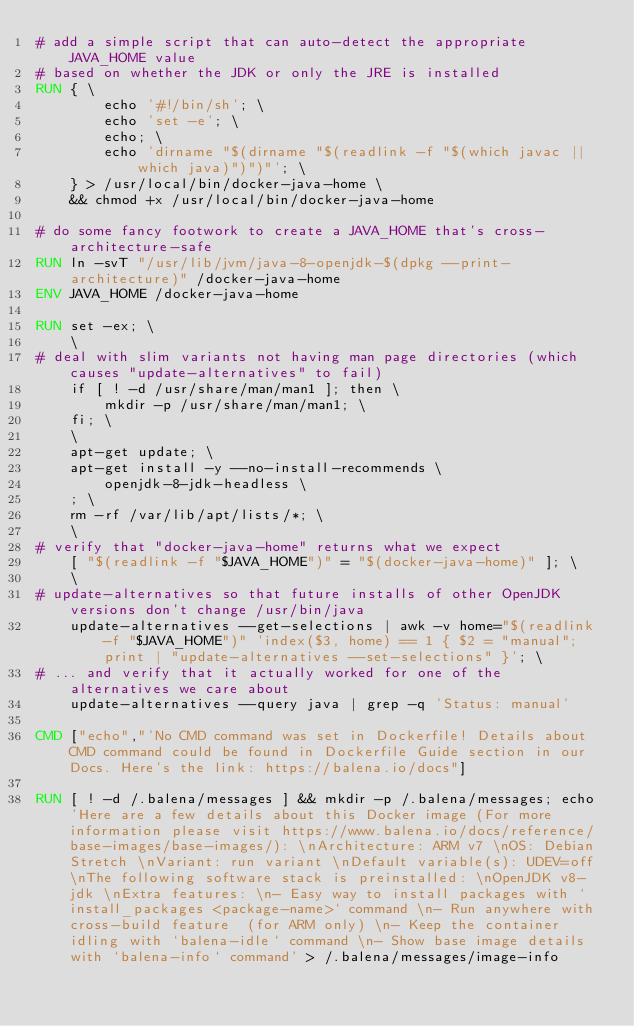Convert code to text. <code><loc_0><loc_0><loc_500><loc_500><_Dockerfile_># add a simple script that can auto-detect the appropriate JAVA_HOME value
# based on whether the JDK or only the JRE is installed
RUN { \
		echo '#!/bin/sh'; \
		echo 'set -e'; \
		echo; \
		echo 'dirname "$(dirname "$(readlink -f "$(which javac || which java)")")"'; \
	} > /usr/local/bin/docker-java-home \
	&& chmod +x /usr/local/bin/docker-java-home

# do some fancy footwork to create a JAVA_HOME that's cross-architecture-safe
RUN ln -svT "/usr/lib/jvm/java-8-openjdk-$(dpkg --print-architecture)" /docker-java-home
ENV JAVA_HOME /docker-java-home

RUN set -ex; \
	\
# deal with slim variants not having man page directories (which causes "update-alternatives" to fail)
	if [ ! -d /usr/share/man/man1 ]; then \
		mkdir -p /usr/share/man/man1; \
	fi; \
	\
	apt-get update; \
	apt-get install -y --no-install-recommends \
		openjdk-8-jdk-headless \
	; \
	rm -rf /var/lib/apt/lists/*; \
	\
# verify that "docker-java-home" returns what we expect
	[ "$(readlink -f "$JAVA_HOME")" = "$(docker-java-home)" ]; \
	\
# update-alternatives so that future installs of other OpenJDK versions don't change /usr/bin/java
	update-alternatives --get-selections | awk -v home="$(readlink -f "$JAVA_HOME")" 'index($3, home) == 1 { $2 = "manual"; print | "update-alternatives --set-selections" }'; \
# ... and verify that it actually worked for one of the alternatives we care about
	update-alternatives --query java | grep -q 'Status: manual'

CMD ["echo","'No CMD command was set in Dockerfile! Details about CMD command could be found in Dockerfile Guide section in our Docs. Here's the link: https://balena.io/docs"]

RUN [ ! -d /.balena/messages ] && mkdir -p /.balena/messages; echo 'Here are a few details about this Docker image (For more information please visit https://www.balena.io/docs/reference/base-images/base-images/): \nArchitecture: ARM v7 \nOS: Debian Stretch \nVariant: run variant \nDefault variable(s): UDEV=off \nThe following software stack is preinstalled: \nOpenJDK v8-jdk \nExtra features: \n- Easy way to install packages with `install_packages <package-name>` command \n- Run anywhere with cross-build feature  (for ARM only) \n- Keep the container idling with `balena-idle` command \n- Show base image details with `balena-info` command' > /.balena/messages/image-info</code> 